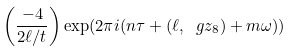Convert formula to latex. <formula><loc_0><loc_0><loc_500><loc_500>\left ( \frac { - 4 } { 2 \ell / t } \right ) \exp ( 2 \pi i ( n \tau + ( \ell , \ g z _ { 8 } ) + m \omega ) )</formula> 